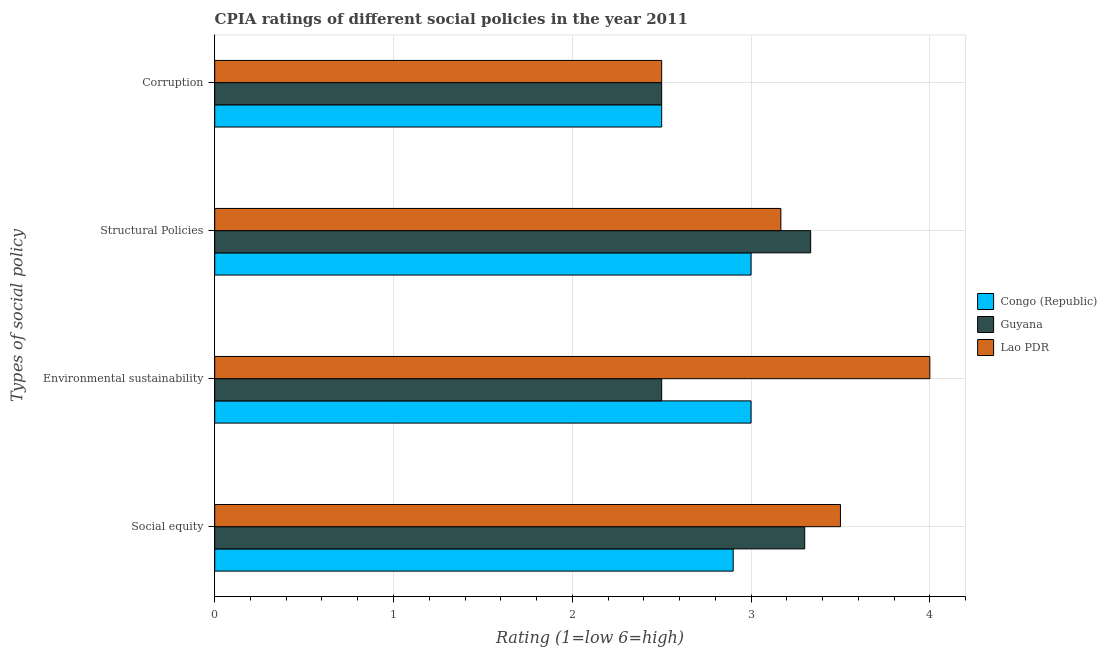How many different coloured bars are there?
Your answer should be very brief. 3. How many bars are there on the 1st tick from the top?
Provide a succinct answer. 3. What is the label of the 2nd group of bars from the top?
Make the answer very short. Structural Policies. What is the cpia rating of structural policies in Congo (Republic)?
Your answer should be compact. 3. In which country was the cpia rating of environmental sustainability maximum?
Your response must be concise. Lao PDR. In which country was the cpia rating of social equity minimum?
Provide a short and direct response. Congo (Republic). What is the total cpia rating of social equity in the graph?
Offer a terse response. 9.7. What is the difference between the cpia rating of structural policies in Congo (Republic) and that in Lao PDR?
Offer a terse response. -0.17. What is the difference between the cpia rating of social equity in Lao PDR and the cpia rating of structural policies in Guyana?
Give a very brief answer. 0.17. What is the average cpia rating of structural policies per country?
Provide a short and direct response. 3.17. In how many countries, is the cpia rating of structural policies greater than 3.8 ?
Your answer should be very brief. 0. What is the ratio of the cpia rating of structural policies in Lao PDR to that in Guyana?
Make the answer very short. 0.95. Is the cpia rating of environmental sustainability in Congo (Republic) less than that in Guyana?
Your response must be concise. No. Is the difference between the cpia rating of environmental sustainability in Guyana and Lao PDR greater than the difference between the cpia rating of social equity in Guyana and Lao PDR?
Your response must be concise. No. What is the difference between the highest and the second highest cpia rating of corruption?
Make the answer very short. 0. In how many countries, is the cpia rating of structural policies greater than the average cpia rating of structural policies taken over all countries?
Your answer should be compact. 2. What does the 3rd bar from the top in Social equity represents?
Your answer should be compact. Congo (Republic). What does the 2nd bar from the bottom in Structural Policies represents?
Offer a terse response. Guyana. Is it the case that in every country, the sum of the cpia rating of social equity and cpia rating of environmental sustainability is greater than the cpia rating of structural policies?
Your answer should be very brief. Yes. Does the graph contain grids?
Your answer should be very brief. Yes. What is the title of the graph?
Provide a succinct answer. CPIA ratings of different social policies in the year 2011. Does "Sint Maarten (Dutch part)" appear as one of the legend labels in the graph?
Give a very brief answer. No. What is the label or title of the Y-axis?
Your answer should be compact. Types of social policy. What is the Rating (1=low 6=high) in Congo (Republic) in Environmental sustainability?
Your answer should be compact. 3. What is the Rating (1=low 6=high) of Guyana in Environmental sustainability?
Keep it short and to the point. 2.5. What is the Rating (1=low 6=high) in Lao PDR in Environmental sustainability?
Offer a very short reply. 4. What is the Rating (1=low 6=high) of Guyana in Structural Policies?
Offer a very short reply. 3.33. What is the Rating (1=low 6=high) of Lao PDR in Structural Policies?
Provide a succinct answer. 3.17. What is the Rating (1=low 6=high) in Congo (Republic) in Corruption?
Offer a very short reply. 2.5. What is the Rating (1=low 6=high) in Lao PDR in Corruption?
Provide a short and direct response. 2.5. Across all Types of social policy, what is the maximum Rating (1=low 6=high) of Congo (Republic)?
Provide a succinct answer. 3. Across all Types of social policy, what is the maximum Rating (1=low 6=high) of Guyana?
Your answer should be very brief. 3.33. Across all Types of social policy, what is the maximum Rating (1=low 6=high) of Lao PDR?
Give a very brief answer. 4. Across all Types of social policy, what is the minimum Rating (1=low 6=high) in Congo (Republic)?
Your answer should be compact. 2.5. Across all Types of social policy, what is the minimum Rating (1=low 6=high) of Lao PDR?
Offer a very short reply. 2.5. What is the total Rating (1=low 6=high) in Congo (Republic) in the graph?
Keep it short and to the point. 11.4. What is the total Rating (1=low 6=high) of Guyana in the graph?
Give a very brief answer. 11.63. What is the total Rating (1=low 6=high) in Lao PDR in the graph?
Your response must be concise. 13.17. What is the difference between the Rating (1=low 6=high) of Congo (Republic) in Social equity and that in Environmental sustainability?
Provide a short and direct response. -0.1. What is the difference between the Rating (1=low 6=high) of Lao PDR in Social equity and that in Environmental sustainability?
Ensure brevity in your answer.  -0.5. What is the difference between the Rating (1=low 6=high) of Congo (Republic) in Social equity and that in Structural Policies?
Your answer should be compact. -0.1. What is the difference between the Rating (1=low 6=high) in Guyana in Social equity and that in Structural Policies?
Offer a terse response. -0.03. What is the difference between the Rating (1=low 6=high) of Lao PDR in Social equity and that in Corruption?
Ensure brevity in your answer.  1. What is the difference between the Rating (1=low 6=high) in Guyana in Environmental sustainability and that in Structural Policies?
Keep it short and to the point. -0.83. What is the difference between the Rating (1=low 6=high) of Lao PDR in Environmental sustainability and that in Structural Policies?
Keep it short and to the point. 0.83. What is the difference between the Rating (1=low 6=high) of Congo (Republic) in Environmental sustainability and that in Corruption?
Provide a short and direct response. 0.5. What is the difference between the Rating (1=low 6=high) in Lao PDR in Environmental sustainability and that in Corruption?
Make the answer very short. 1.5. What is the difference between the Rating (1=low 6=high) of Congo (Republic) in Structural Policies and that in Corruption?
Your answer should be compact. 0.5. What is the difference between the Rating (1=low 6=high) of Lao PDR in Structural Policies and that in Corruption?
Your response must be concise. 0.67. What is the difference between the Rating (1=low 6=high) of Congo (Republic) in Social equity and the Rating (1=low 6=high) of Lao PDR in Environmental sustainability?
Provide a short and direct response. -1.1. What is the difference between the Rating (1=low 6=high) in Congo (Republic) in Social equity and the Rating (1=low 6=high) in Guyana in Structural Policies?
Make the answer very short. -0.43. What is the difference between the Rating (1=low 6=high) of Congo (Republic) in Social equity and the Rating (1=low 6=high) of Lao PDR in Structural Policies?
Offer a terse response. -0.27. What is the difference between the Rating (1=low 6=high) in Guyana in Social equity and the Rating (1=low 6=high) in Lao PDR in Structural Policies?
Offer a terse response. 0.13. What is the difference between the Rating (1=low 6=high) in Congo (Republic) in Social equity and the Rating (1=low 6=high) in Guyana in Corruption?
Give a very brief answer. 0.4. What is the difference between the Rating (1=low 6=high) of Congo (Republic) in Social equity and the Rating (1=low 6=high) of Lao PDR in Corruption?
Ensure brevity in your answer.  0.4. What is the difference between the Rating (1=low 6=high) of Congo (Republic) in Environmental sustainability and the Rating (1=low 6=high) of Guyana in Structural Policies?
Your answer should be very brief. -0.33. What is the difference between the Rating (1=low 6=high) of Guyana in Environmental sustainability and the Rating (1=low 6=high) of Lao PDR in Structural Policies?
Keep it short and to the point. -0.67. What is the difference between the Rating (1=low 6=high) of Congo (Republic) in Environmental sustainability and the Rating (1=low 6=high) of Guyana in Corruption?
Offer a very short reply. 0.5. What is the difference between the Rating (1=low 6=high) in Congo (Republic) in Environmental sustainability and the Rating (1=low 6=high) in Lao PDR in Corruption?
Provide a succinct answer. 0.5. What is the difference between the Rating (1=low 6=high) in Congo (Republic) in Structural Policies and the Rating (1=low 6=high) in Guyana in Corruption?
Provide a succinct answer. 0.5. What is the average Rating (1=low 6=high) of Congo (Republic) per Types of social policy?
Provide a short and direct response. 2.85. What is the average Rating (1=low 6=high) in Guyana per Types of social policy?
Keep it short and to the point. 2.91. What is the average Rating (1=low 6=high) of Lao PDR per Types of social policy?
Make the answer very short. 3.29. What is the difference between the Rating (1=low 6=high) in Guyana and Rating (1=low 6=high) in Lao PDR in Social equity?
Your answer should be compact. -0.2. What is the difference between the Rating (1=low 6=high) in Congo (Republic) and Rating (1=low 6=high) in Guyana in Environmental sustainability?
Your answer should be very brief. 0.5. What is the difference between the Rating (1=low 6=high) of Congo (Republic) and Rating (1=low 6=high) of Lao PDR in Environmental sustainability?
Give a very brief answer. -1. What is the difference between the Rating (1=low 6=high) of Guyana and Rating (1=low 6=high) of Lao PDR in Environmental sustainability?
Provide a succinct answer. -1.5. What is the difference between the Rating (1=low 6=high) in Congo (Republic) and Rating (1=low 6=high) in Guyana in Structural Policies?
Give a very brief answer. -0.33. What is the difference between the Rating (1=low 6=high) of Congo (Republic) and Rating (1=low 6=high) of Guyana in Corruption?
Provide a short and direct response. 0. What is the difference between the Rating (1=low 6=high) in Guyana and Rating (1=low 6=high) in Lao PDR in Corruption?
Your answer should be compact. 0. What is the ratio of the Rating (1=low 6=high) of Congo (Republic) in Social equity to that in Environmental sustainability?
Make the answer very short. 0.97. What is the ratio of the Rating (1=low 6=high) of Guyana in Social equity to that in Environmental sustainability?
Ensure brevity in your answer.  1.32. What is the ratio of the Rating (1=low 6=high) in Lao PDR in Social equity to that in Environmental sustainability?
Ensure brevity in your answer.  0.88. What is the ratio of the Rating (1=low 6=high) of Congo (Republic) in Social equity to that in Structural Policies?
Keep it short and to the point. 0.97. What is the ratio of the Rating (1=low 6=high) of Guyana in Social equity to that in Structural Policies?
Offer a very short reply. 0.99. What is the ratio of the Rating (1=low 6=high) in Lao PDR in Social equity to that in Structural Policies?
Your answer should be very brief. 1.11. What is the ratio of the Rating (1=low 6=high) of Congo (Republic) in Social equity to that in Corruption?
Your answer should be very brief. 1.16. What is the ratio of the Rating (1=low 6=high) in Guyana in Social equity to that in Corruption?
Keep it short and to the point. 1.32. What is the ratio of the Rating (1=low 6=high) in Lao PDR in Environmental sustainability to that in Structural Policies?
Provide a short and direct response. 1.26. What is the ratio of the Rating (1=low 6=high) in Lao PDR in Structural Policies to that in Corruption?
Make the answer very short. 1.27. What is the difference between the highest and the second highest Rating (1=low 6=high) of Congo (Republic)?
Your answer should be compact. 0. What is the difference between the highest and the second highest Rating (1=low 6=high) of Guyana?
Your response must be concise. 0.03. What is the difference between the highest and the lowest Rating (1=low 6=high) in Congo (Republic)?
Provide a succinct answer. 0.5. 